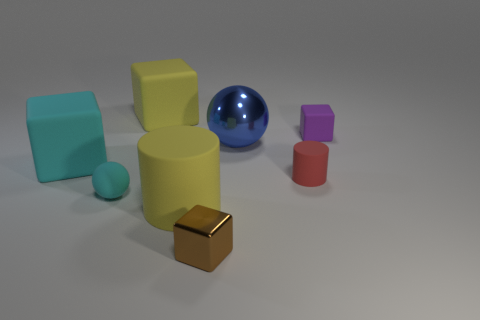Subtract all yellow cubes. How many cubes are left? 3 Subtract all blue blocks. Subtract all cyan balls. How many blocks are left? 4 Add 2 large cyan matte cubes. How many objects exist? 10 Subtract all spheres. How many objects are left? 6 Subtract 0 blue cylinders. How many objects are left? 8 Subtract all metal blocks. Subtract all cyan rubber spheres. How many objects are left? 6 Add 3 tiny red cylinders. How many tiny red cylinders are left? 4 Add 3 tiny red things. How many tiny red things exist? 4 